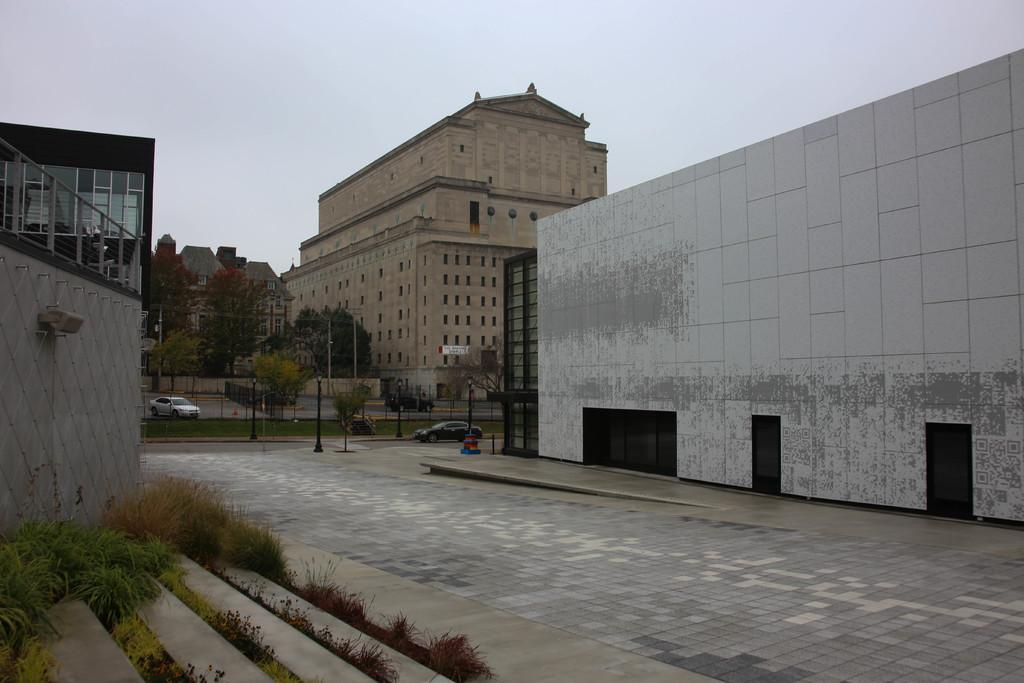What type of structures can be seen in the image? There are buildings in the image. What type of vehicles are present in the image? There are cars in the image. What type of vegetation is visible in the image? There are trees and grass in the image. What architectural features can be seen in the image? There are steps and a wall in the image. What is visible in the background of the image? The sky is visible in the background of the image. Can you hear the thunder in the image? There is no sound present in the image, so it is not possible to hear thunder. Is there a plane flying in the image? There is no plane visible in the image. 